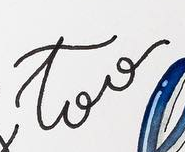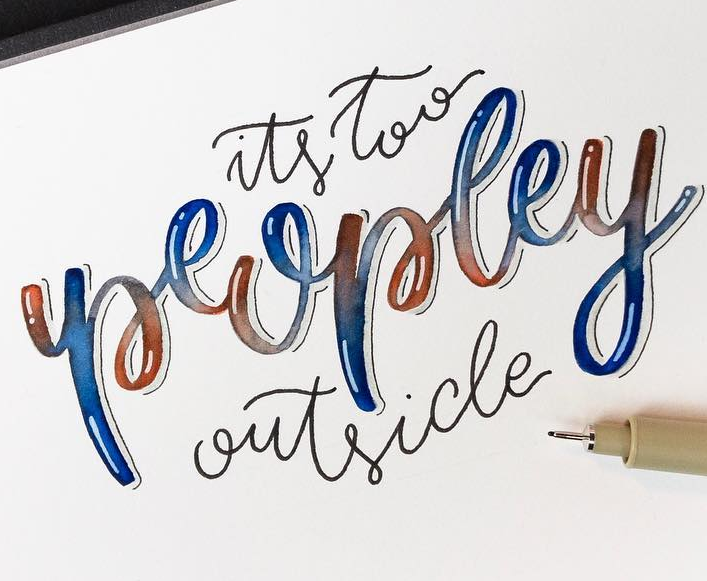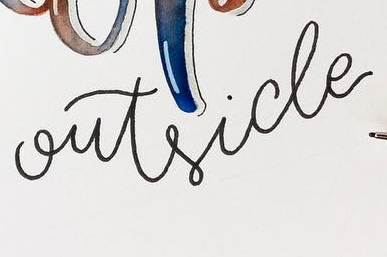What text appears in these images from left to right, separated by a semicolon? too; peopley; outside 